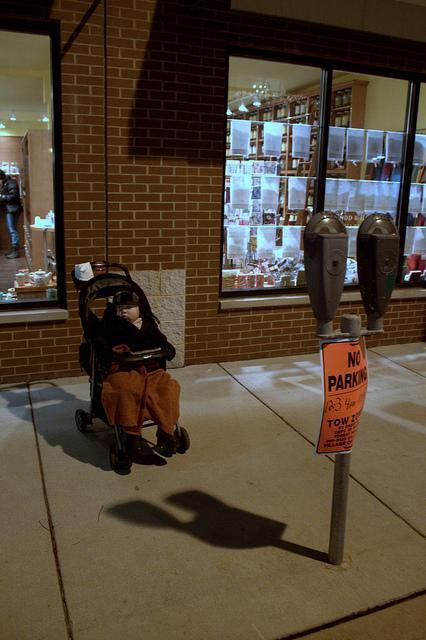How many parking meters are in the photo?
Give a very brief answer. 2. How many donuts are left?
Give a very brief answer. 0. 